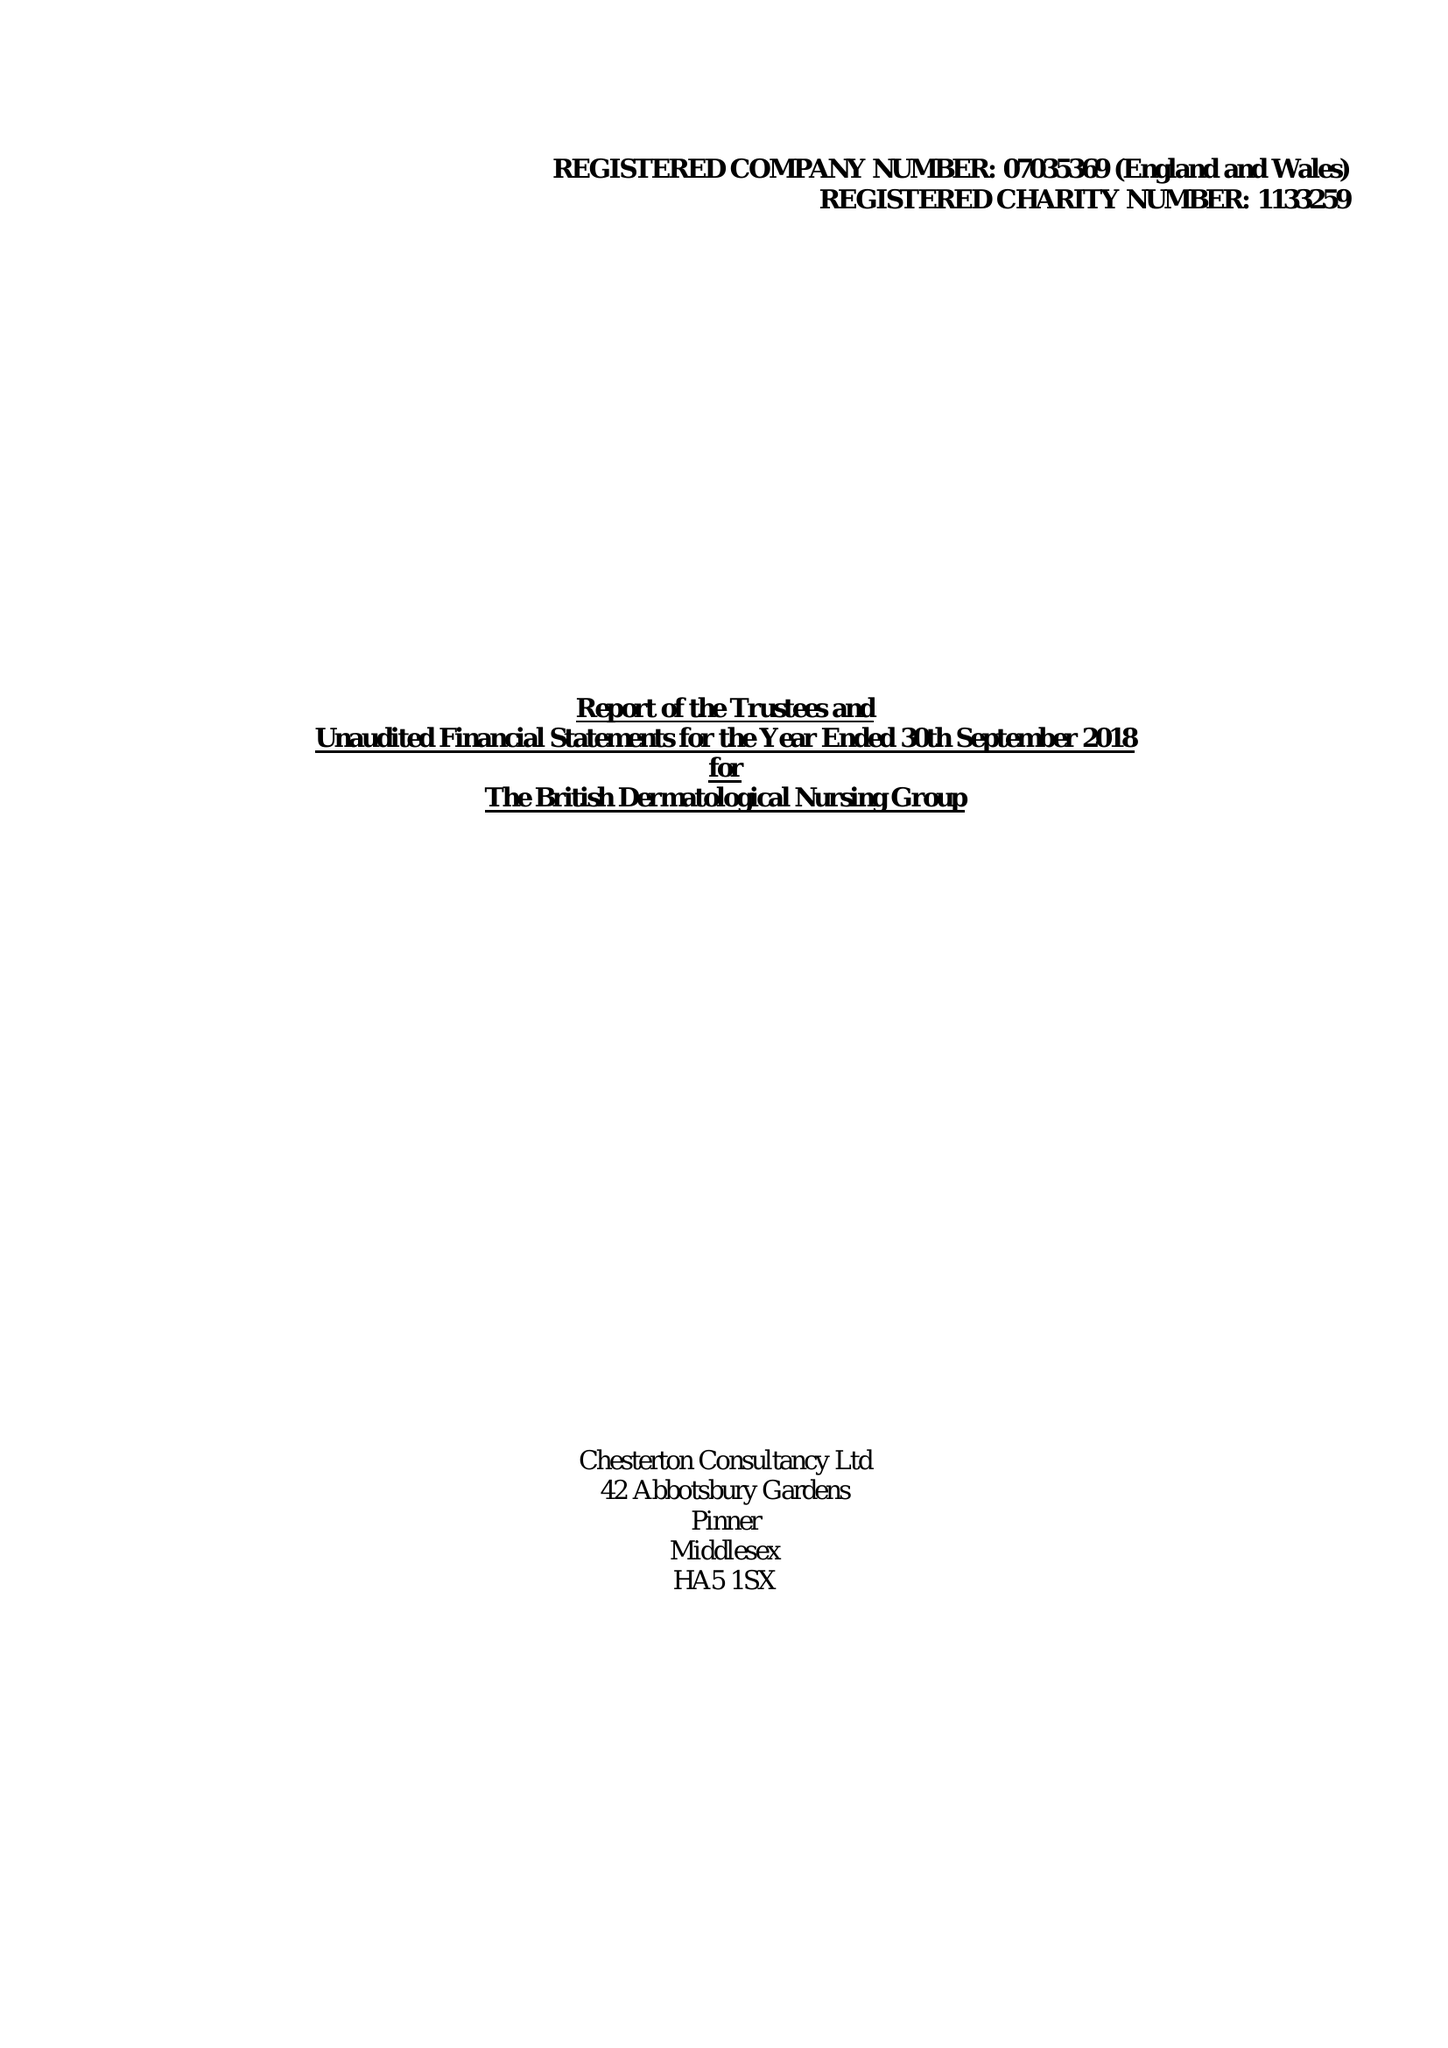What is the value for the address__post_town?
Answer the question using a single word or phrase. LONDON 